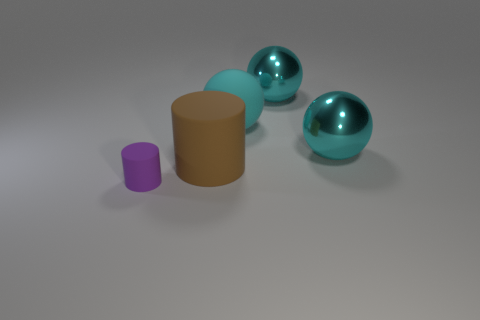Subtract all cyan spheres. How many were subtracted if there are1cyan spheres left? 2 Subtract all purple cylinders. How many cylinders are left? 1 Subtract all cyan metallic balls. How many balls are left? 1 Add 2 rubber objects. How many objects exist? 7 Subtract all spheres. How many objects are left? 2 Subtract 2 cylinders. How many cylinders are left? 0 Subtract all cyan cylinders. Subtract all cyan blocks. How many cylinders are left? 2 Subtract all yellow spheres. How many brown cylinders are left? 1 Subtract all cyan things. Subtract all matte cylinders. How many objects are left? 0 Add 1 big cylinders. How many big cylinders are left? 2 